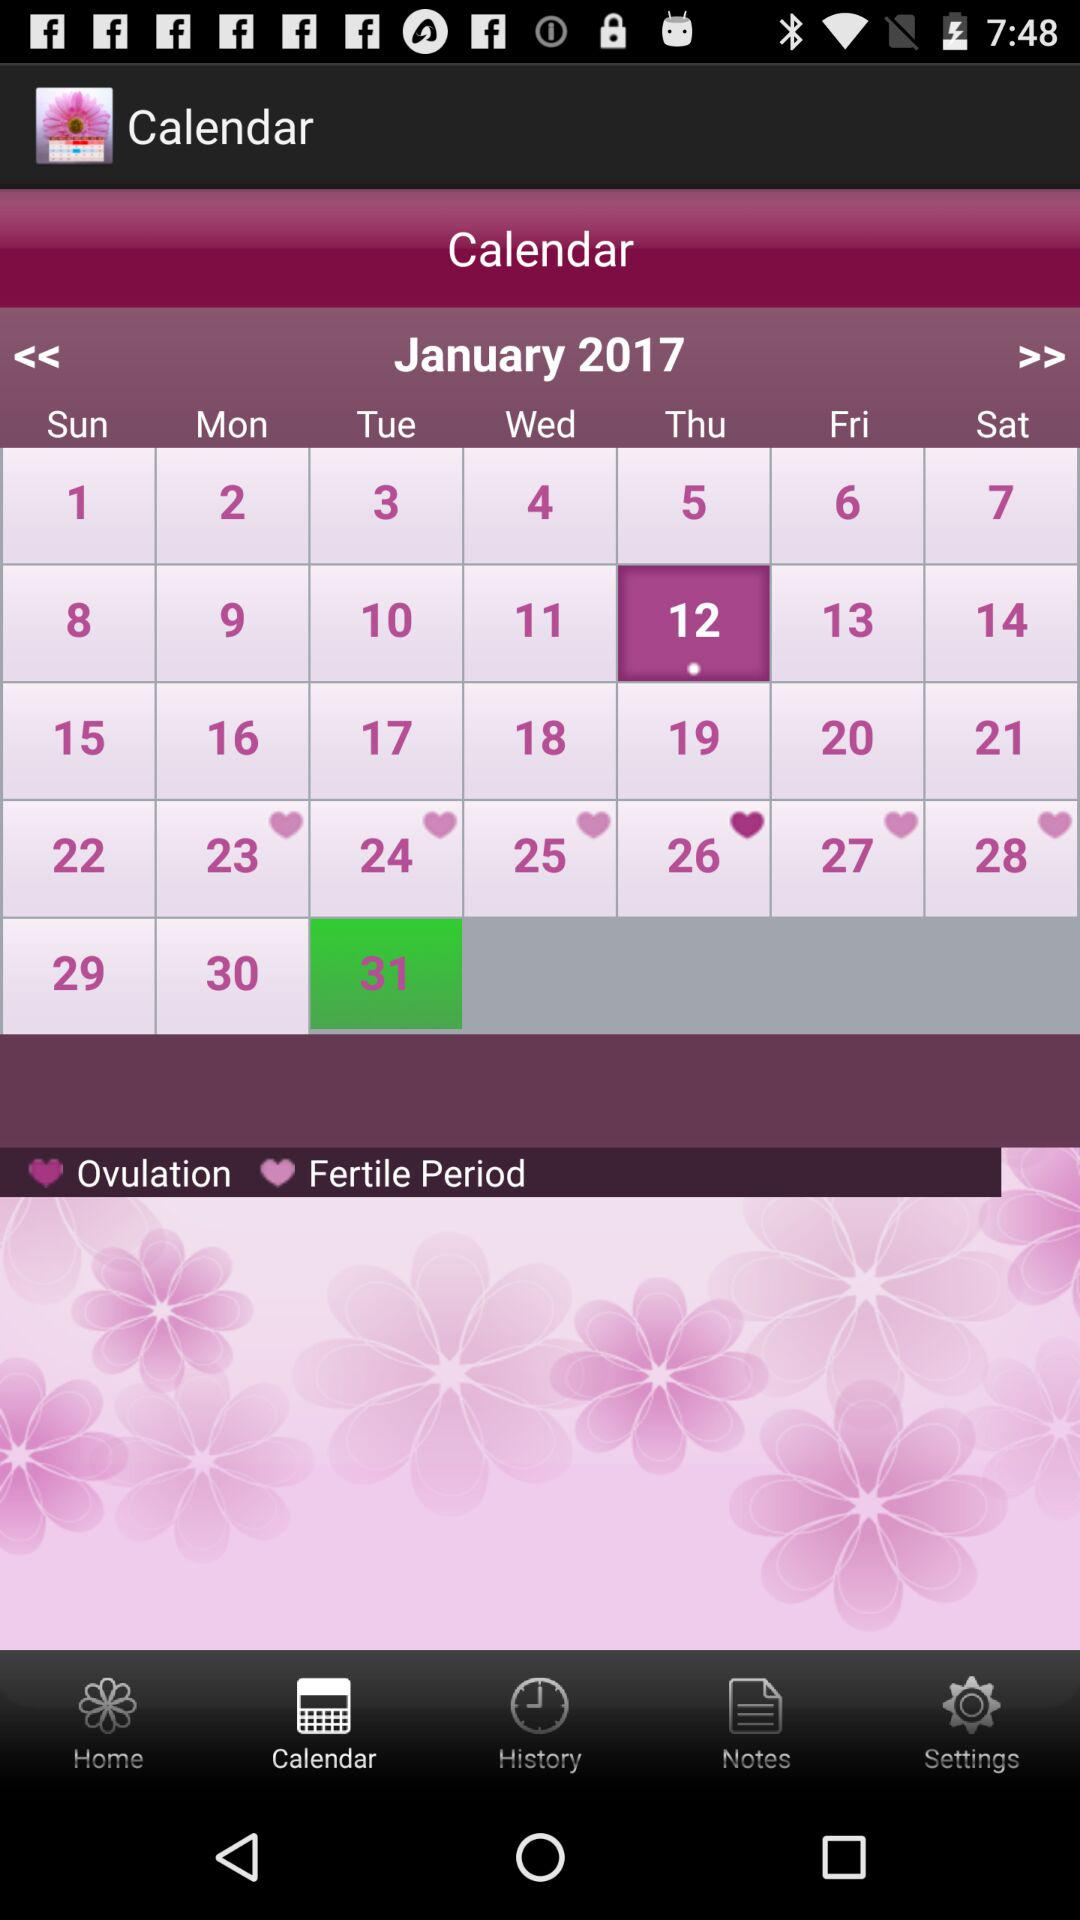How many notifications are there in "Notes"?
When the provided information is insufficient, respond with <no answer>. <no answer> 